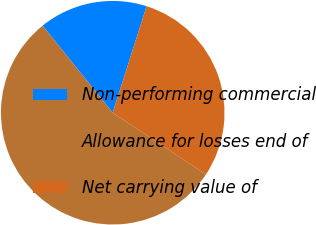Convert chart to OTSL. <chart><loc_0><loc_0><loc_500><loc_500><pie_chart><fcel>Non-performing commercial<fcel>Allowance for losses end of<fcel>Net carrying value of<nl><fcel>15.69%<fcel>54.9%<fcel>29.41%<nl></chart> 